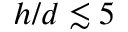<formula> <loc_0><loc_0><loc_500><loc_500>h / d \lesssim 5</formula> 